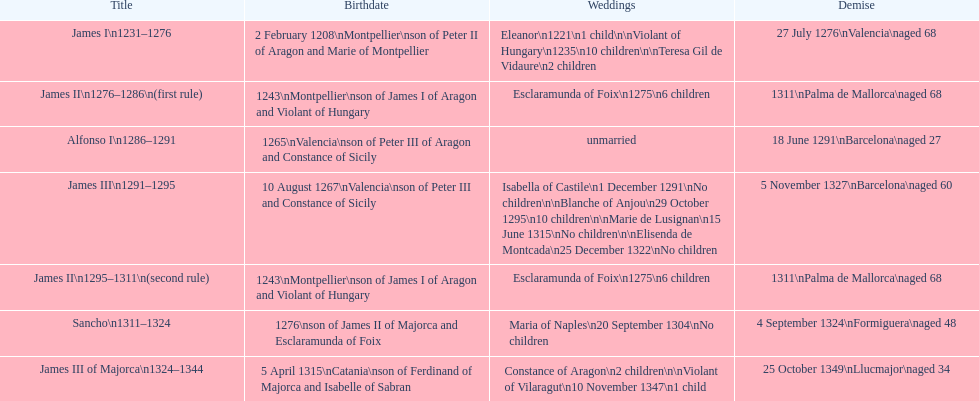What name is above james iii and below james ii? Alfonso I. Could you parse the entire table as a dict? {'header': ['Title', 'Birthdate', 'Weddings', 'Demise'], 'rows': [['James I\\n1231–1276', '2 February 1208\\nMontpellier\\nson of Peter II of Aragon and Marie of Montpellier', 'Eleanor\\n1221\\n1 child\\n\\nViolant of Hungary\\n1235\\n10 children\\n\\nTeresa Gil de Vidaure\\n2 children', '27 July 1276\\nValencia\\naged 68'], ['James II\\n1276–1286\\n(first rule)', '1243\\nMontpellier\\nson of James I of Aragon and Violant of Hungary', 'Esclaramunda of Foix\\n1275\\n6 children', '1311\\nPalma de Mallorca\\naged 68'], ['Alfonso I\\n1286–1291', '1265\\nValencia\\nson of Peter III of Aragon and Constance of Sicily', 'unmarried', '18 June 1291\\nBarcelona\\naged 27'], ['James III\\n1291–1295', '10 August 1267\\nValencia\\nson of Peter III and Constance of Sicily', 'Isabella of Castile\\n1 December 1291\\nNo children\\n\\nBlanche of Anjou\\n29 October 1295\\n10 children\\n\\nMarie de Lusignan\\n15 June 1315\\nNo children\\n\\nElisenda de Montcada\\n25 December 1322\\nNo children', '5 November 1327\\nBarcelona\\naged 60'], ['James II\\n1295–1311\\n(second rule)', '1243\\nMontpellier\\nson of James I of Aragon and Violant of Hungary', 'Esclaramunda of Foix\\n1275\\n6 children', '1311\\nPalma de Mallorca\\naged 68'], ['Sancho\\n1311–1324', '1276\\nson of James II of Majorca and Esclaramunda of Foix', 'Maria of Naples\\n20 September 1304\\nNo children', '4 September 1324\\nFormiguera\\naged 48'], ['James III of Majorca\\n1324–1344', '5 April 1315\\nCatania\\nson of Ferdinand of Majorca and Isabelle of Sabran', 'Constance of Aragon\\n2 children\\n\\nViolant of Vilaragut\\n10 November 1347\\n1 child', '25 October 1349\\nLlucmajor\\naged 34']]} 